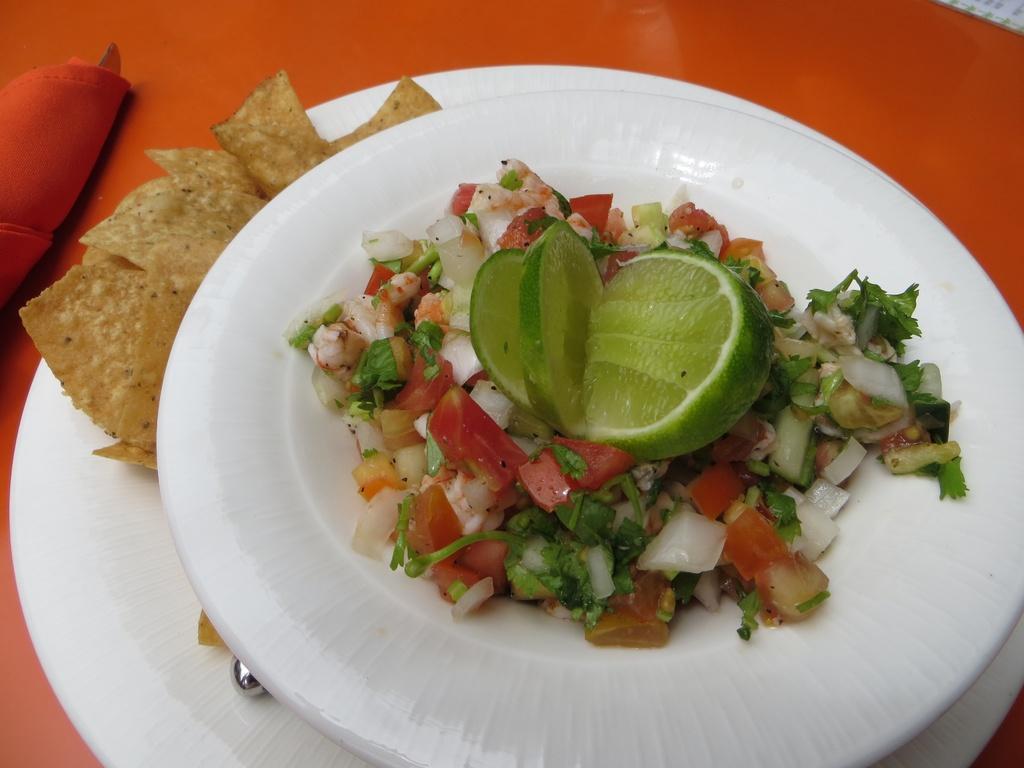Can you describe this image briefly? In this image we can see food, a lemon and a spoon placed on plates. On the left side of the image we can see a cloth placed on the surface 